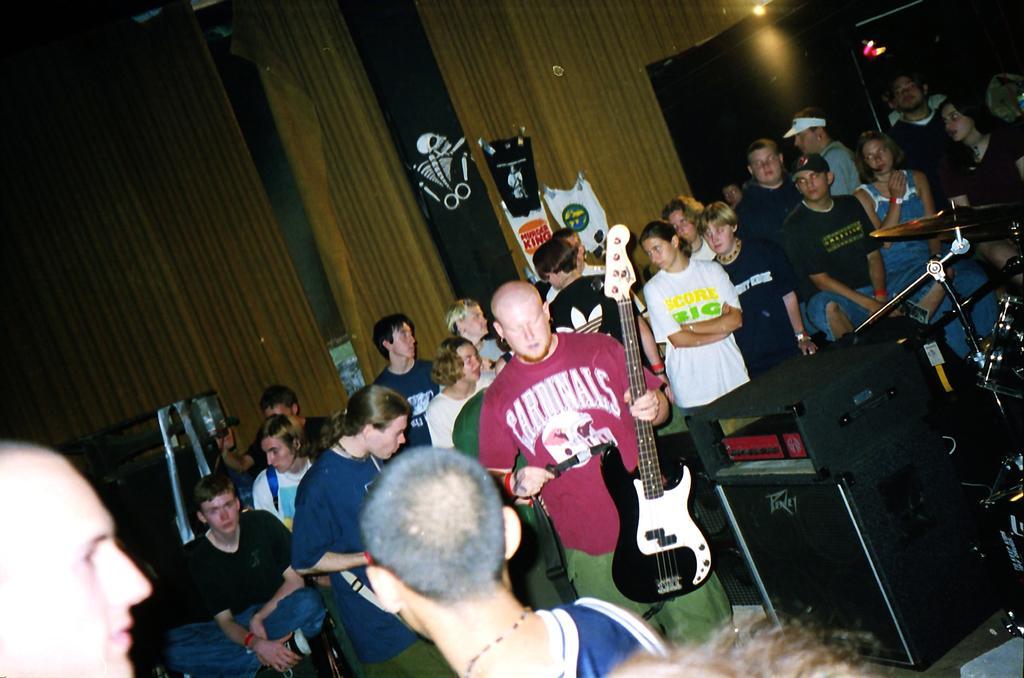Describe this image in one or two sentences. this is an inside view picture. On the background we can see curtains and few boards and carry bags. Here we can see all the persons standing, sitting. A man with pink colour shirt is holding a guitar in his hand. These are drums and it's a cymbal. 